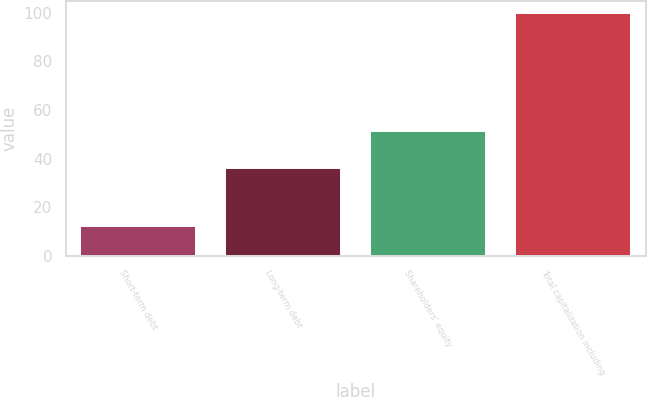Convert chart. <chart><loc_0><loc_0><loc_500><loc_500><bar_chart><fcel>Short-term debt<fcel>Long-term debt<fcel>Shareholders' equity<fcel>Total capitalization including<nl><fcel>12.3<fcel>36.2<fcel>51.5<fcel>100<nl></chart> 